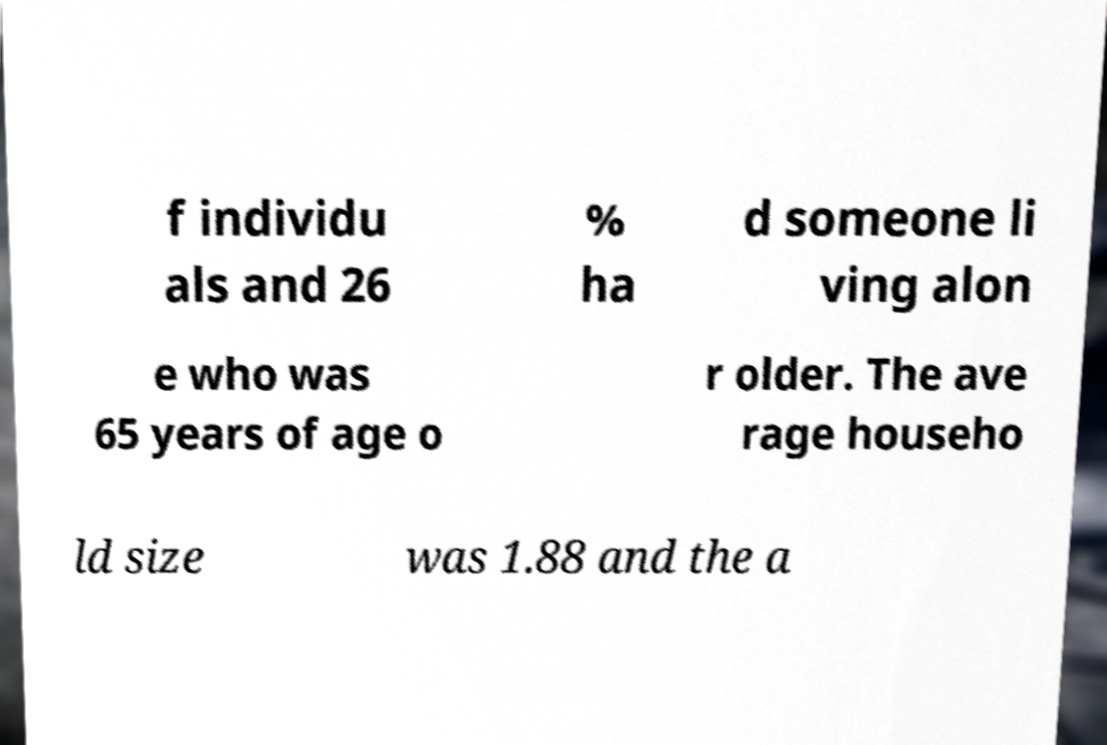Can you read and provide the text displayed in the image?This photo seems to have some interesting text. Can you extract and type it out for me? f individu als and 26 % ha d someone li ving alon e who was 65 years of age o r older. The ave rage househo ld size was 1.88 and the a 